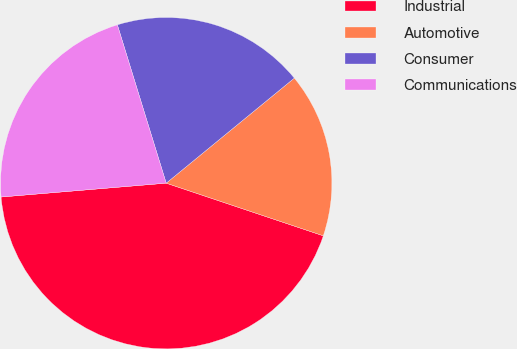Convert chart. <chart><loc_0><loc_0><loc_500><loc_500><pie_chart><fcel>Industrial<fcel>Automotive<fcel>Consumer<fcel>Communications<nl><fcel>43.52%<fcel>16.08%<fcel>18.83%<fcel>21.57%<nl></chart> 